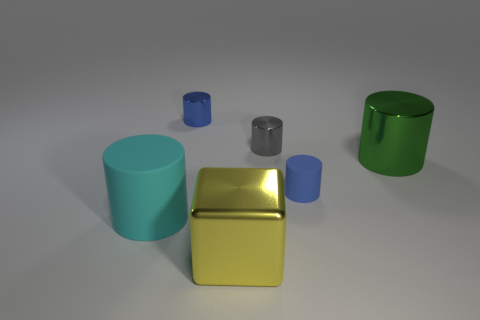The large green metal thing that is on the right side of the tiny cylinder that is in front of the large green cylinder on the right side of the tiny gray thing is what shape?
Provide a succinct answer. Cylinder. What number of other things are there of the same material as the gray cylinder
Make the answer very short. 3. What number of objects are rubber objects behind the large cyan matte thing or small cyan rubber things?
Ensure brevity in your answer.  1. There is a large metallic thing that is to the left of the blue object in front of the blue metallic cylinder; what shape is it?
Your response must be concise. Cube. There is a blue object to the right of the large yellow metallic cube; does it have the same shape as the gray metallic object?
Keep it short and to the point. Yes. There is a tiny cylinder that is in front of the large green shiny object; what is its color?
Give a very brief answer. Blue. How many cylinders are either large metal things or cyan rubber objects?
Your answer should be compact. 2. What size is the green shiny object that is right of the large metal thing in front of the big green object?
Offer a very short reply. Large. Do the big block and the cylinder in front of the blue matte thing have the same color?
Offer a very short reply. No. How many gray cylinders are in front of the big metal cylinder?
Your response must be concise. 0. 